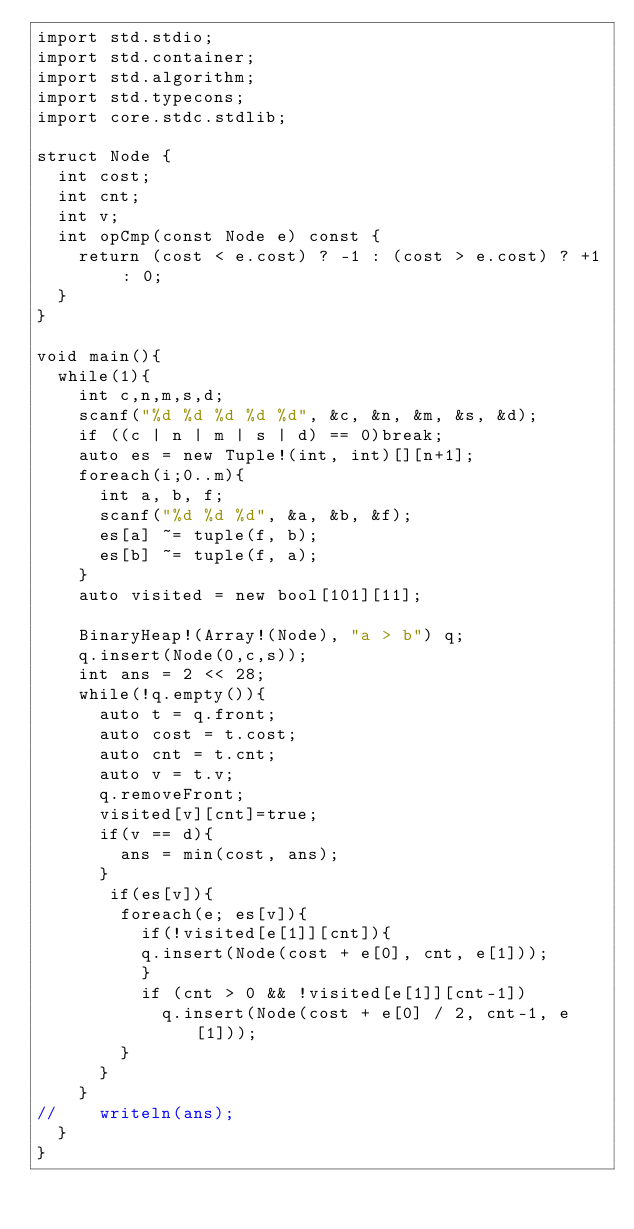<code> <loc_0><loc_0><loc_500><loc_500><_D_>import std.stdio;
import std.container;
import std.algorithm;
import std.typecons;
import core.stdc.stdlib;

struct Node {
  int cost;
  int cnt;
  int v;
  int opCmp(const Node e) const {
    return (cost < e.cost) ? -1 : (cost > e.cost) ? +1 : 0;
  }
}

void main(){
  while(1){
    int c,n,m,s,d;
    scanf("%d %d %d %d %d", &c, &n, &m, &s, &d);
    if ((c | n | m | s | d) == 0)break;
    auto es = new Tuple!(int, int)[][n+1];
    foreach(i;0..m){
      int a, b, f;
      scanf("%d %d %d", &a, &b, &f);
      es[a] ~= tuple(f, b);
      es[b] ~= tuple(f, a);
    }
    auto visited = new bool[101][11];

    BinaryHeap!(Array!(Node), "a > b") q;
    q.insert(Node(0,c,s));
    int ans = 2 << 28;
    while(!q.empty()){
      auto t = q.front;
      auto cost = t.cost;
      auto cnt = t.cnt;
      auto v = t.v;
      q.removeFront;
      visited[v][cnt]=true;
      if(v == d){
        ans = min(cost, ans);
      }
       if(es[v]){
        foreach(e; es[v]){
          if(!visited[e[1]][cnt]){
          q.insert(Node(cost + e[0], cnt, e[1]));
          }
          if (cnt > 0 && !visited[e[1]][cnt-1])
            q.insert(Node(cost + e[0] / 2, cnt-1, e[1]));
        }
      }
    }
//    writeln(ans);
  }
}</code> 